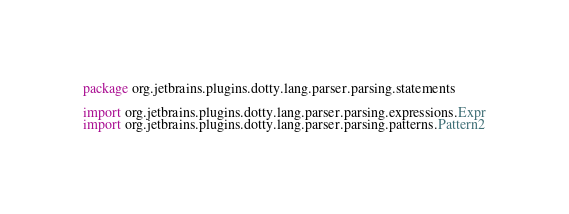Convert code to text. <code><loc_0><loc_0><loc_500><loc_500><_Scala_>package org.jetbrains.plugins.dotty.lang.parser.parsing.statements

import org.jetbrains.plugins.dotty.lang.parser.parsing.expressions.Expr
import org.jetbrains.plugins.dotty.lang.parser.parsing.patterns.Pattern2</code> 